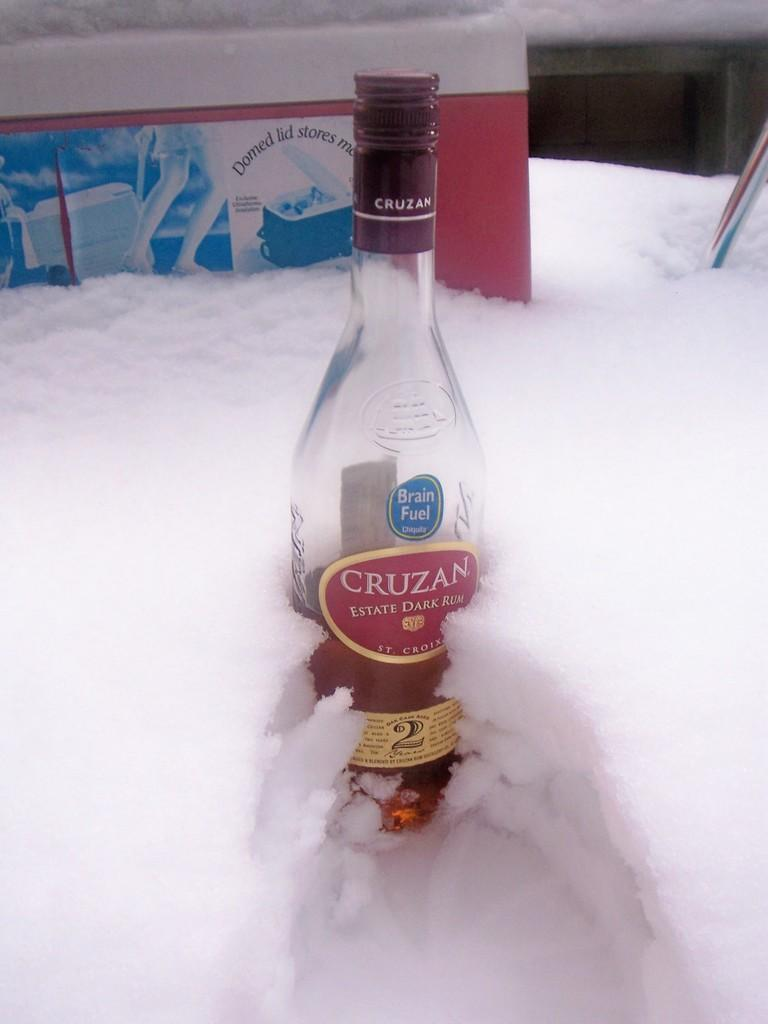Provide a one-sentence caption for the provided image. A bottle of Cruzan is in front of a Domed Lid Store product. 